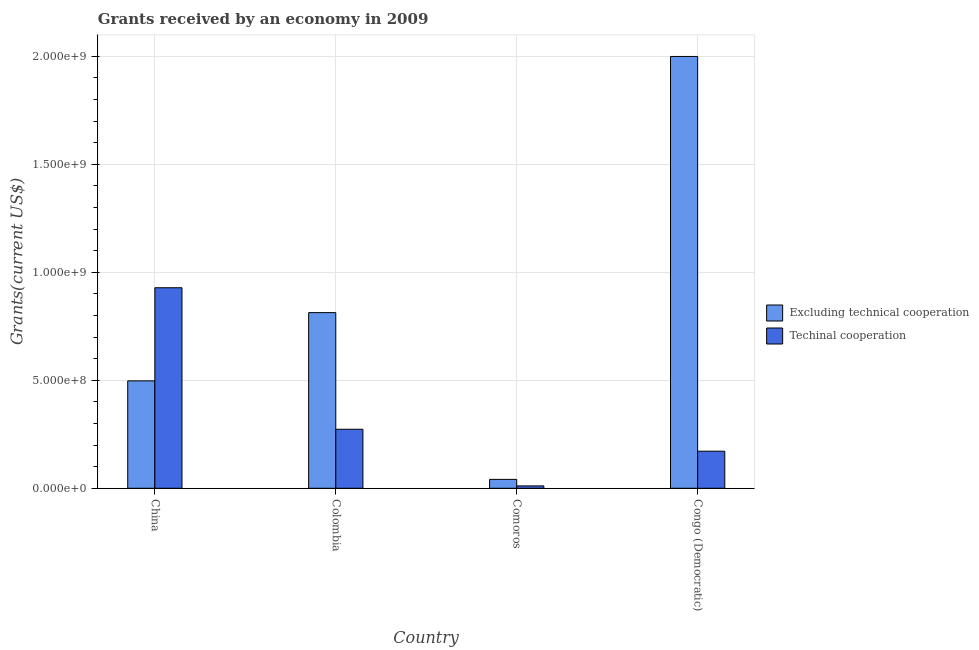What is the label of the 3rd group of bars from the left?
Make the answer very short. Comoros. In how many cases, is the number of bars for a given country not equal to the number of legend labels?
Keep it short and to the point. 0. What is the amount of grants received(including technical cooperation) in Colombia?
Your answer should be very brief. 2.73e+08. Across all countries, what is the maximum amount of grants received(excluding technical cooperation)?
Offer a terse response. 2.00e+09. Across all countries, what is the minimum amount of grants received(including technical cooperation)?
Your response must be concise. 1.10e+07. In which country was the amount of grants received(including technical cooperation) minimum?
Your answer should be compact. Comoros. What is the total amount of grants received(excluding technical cooperation) in the graph?
Ensure brevity in your answer.  3.35e+09. What is the difference between the amount of grants received(including technical cooperation) in China and that in Congo (Democratic)?
Your answer should be very brief. 7.57e+08. What is the difference between the amount of grants received(excluding technical cooperation) in Colombia and the amount of grants received(including technical cooperation) in Congo (Democratic)?
Your response must be concise. 6.42e+08. What is the average amount of grants received(including technical cooperation) per country?
Your answer should be very brief. 3.46e+08. What is the difference between the amount of grants received(excluding technical cooperation) and amount of grants received(including technical cooperation) in Comoros?
Your response must be concise. 3.01e+07. What is the ratio of the amount of grants received(including technical cooperation) in Colombia to that in Comoros?
Your answer should be compact. 24.75. Is the amount of grants received(including technical cooperation) in China less than that in Colombia?
Provide a short and direct response. No. Is the difference between the amount of grants received(including technical cooperation) in Comoros and Congo (Democratic) greater than the difference between the amount of grants received(excluding technical cooperation) in Comoros and Congo (Democratic)?
Give a very brief answer. Yes. What is the difference between the highest and the second highest amount of grants received(excluding technical cooperation)?
Provide a succinct answer. 1.19e+09. What is the difference between the highest and the lowest amount of grants received(excluding technical cooperation)?
Ensure brevity in your answer.  1.96e+09. What does the 2nd bar from the left in Congo (Democratic) represents?
Provide a succinct answer. Techinal cooperation. What does the 2nd bar from the right in Comoros represents?
Offer a very short reply. Excluding technical cooperation. Does the graph contain grids?
Make the answer very short. Yes. What is the title of the graph?
Provide a succinct answer. Grants received by an economy in 2009. What is the label or title of the X-axis?
Offer a terse response. Country. What is the label or title of the Y-axis?
Offer a terse response. Grants(current US$). What is the Grants(current US$) of Excluding technical cooperation in China?
Offer a very short reply. 4.97e+08. What is the Grants(current US$) of Techinal cooperation in China?
Your answer should be compact. 9.29e+08. What is the Grants(current US$) of Excluding technical cooperation in Colombia?
Your answer should be compact. 8.13e+08. What is the Grants(current US$) of Techinal cooperation in Colombia?
Your answer should be compact. 2.73e+08. What is the Grants(current US$) in Excluding technical cooperation in Comoros?
Provide a short and direct response. 4.12e+07. What is the Grants(current US$) of Techinal cooperation in Comoros?
Offer a very short reply. 1.10e+07. What is the Grants(current US$) of Excluding technical cooperation in Congo (Democratic)?
Keep it short and to the point. 2.00e+09. What is the Grants(current US$) in Techinal cooperation in Congo (Democratic)?
Keep it short and to the point. 1.72e+08. Across all countries, what is the maximum Grants(current US$) in Excluding technical cooperation?
Your response must be concise. 2.00e+09. Across all countries, what is the maximum Grants(current US$) of Techinal cooperation?
Your response must be concise. 9.29e+08. Across all countries, what is the minimum Grants(current US$) of Excluding technical cooperation?
Give a very brief answer. 4.12e+07. Across all countries, what is the minimum Grants(current US$) of Techinal cooperation?
Provide a succinct answer. 1.10e+07. What is the total Grants(current US$) in Excluding technical cooperation in the graph?
Keep it short and to the point. 3.35e+09. What is the total Grants(current US$) in Techinal cooperation in the graph?
Offer a terse response. 1.38e+09. What is the difference between the Grants(current US$) in Excluding technical cooperation in China and that in Colombia?
Offer a very short reply. -3.16e+08. What is the difference between the Grants(current US$) in Techinal cooperation in China and that in Colombia?
Give a very brief answer. 6.55e+08. What is the difference between the Grants(current US$) of Excluding technical cooperation in China and that in Comoros?
Your answer should be compact. 4.56e+08. What is the difference between the Grants(current US$) of Techinal cooperation in China and that in Comoros?
Ensure brevity in your answer.  9.18e+08. What is the difference between the Grants(current US$) in Excluding technical cooperation in China and that in Congo (Democratic)?
Provide a short and direct response. -1.50e+09. What is the difference between the Grants(current US$) of Techinal cooperation in China and that in Congo (Democratic)?
Offer a terse response. 7.57e+08. What is the difference between the Grants(current US$) in Excluding technical cooperation in Colombia and that in Comoros?
Provide a short and direct response. 7.72e+08. What is the difference between the Grants(current US$) in Techinal cooperation in Colombia and that in Comoros?
Keep it short and to the point. 2.62e+08. What is the difference between the Grants(current US$) in Excluding technical cooperation in Colombia and that in Congo (Democratic)?
Make the answer very short. -1.19e+09. What is the difference between the Grants(current US$) in Techinal cooperation in Colombia and that in Congo (Democratic)?
Offer a terse response. 1.02e+08. What is the difference between the Grants(current US$) in Excluding technical cooperation in Comoros and that in Congo (Democratic)?
Give a very brief answer. -1.96e+09. What is the difference between the Grants(current US$) in Techinal cooperation in Comoros and that in Congo (Democratic)?
Give a very brief answer. -1.61e+08. What is the difference between the Grants(current US$) in Excluding technical cooperation in China and the Grants(current US$) in Techinal cooperation in Colombia?
Offer a very short reply. 2.24e+08. What is the difference between the Grants(current US$) of Excluding technical cooperation in China and the Grants(current US$) of Techinal cooperation in Comoros?
Offer a very short reply. 4.86e+08. What is the difference between the Grants(current US$) of Excluding technical cooperation in China and the Grants(current US$) of Techinal cooperation in Congo (Democratic)?
Your answer should be compact. 3.26e+08. What is the difference between the Grants(current US$) in Excluding technical cooperation in Colombia and the Grants(current US$) in Techinal cooperation in Comoros?
Keep it short and to the point. 8.02e+08. What is the difference between the Grants(current US$) of Excluding technical cooperation in Colombia and the Grants(current US$) of Techinal cooperation in Congo (Democratic)?
Offer a terse response. 6.42e+08. What is the difference between the Grants(current US$) in Excluding technical cooperation in Comoros and the Grants(current US$) in Techinal cooperation in Congo (Democratic)?
Provide a short and direct response. -1.31e+08. What is the average Grants(current US$) in Excluding technical cooperation per country?
Ensure brevity in your answer.  8.38e+08. What is the average Grants(current US$) of Techinal cooperation per country?
Offer a very short reply. 3.46e+08. What is the difference between the Grants(current US$) in Excluding technical cooperation and Grants(current US$) in Techinal cooperation in China?
Your answer should be very brief. -4.31e+08. What is the difference between the Grants(current US$) in Excluding technical cooperation and Grants(current US$) in Techinal cooperation in Colombia?
Offer a very short reply. 5.40e+08. What is the difference between the Grants(current US$) of Excluding technical cooperation and Grants(current US$) of Techinal cooperation in Comoros?
Offer a terse response. 3.01e+07. What is the difference between the Grants(current US$) of Excluding technical cooperation and Grants(current US$) of Techinal cooperation in Congo (Democratic)?
Your answer should be very brief. 1.83e+09. What is the ratio of the Grants(current US$) in Excluding technical cooperation in China to that in Colombia?
Make the answer very short. 0.61. What is the ratio of the Grants(current US$) in Techinal cooperation in China to that in Colombia?
Your answer should be compact. 3.4. What is the ratio of the Grants(current US$) in Excluding technical cooperation in China to that in Comoros?
Ensure brevity in your answer.  12.08. What is the ratio of the Grants(current US$) of Techinal cooperation in China to that in Comoros?
Your response must be concise. 84.11. What is the ratio of the Grants(current US$) in Excluding technical cooperation in China to that in Congo (Democratic)?
Your response must be concise. 0.25. What is the ratio of the Grants(current US$) in Techinal cooperation in China to that in Congo (Democratic)?
Provide a short and direct response. 5.41. What is the ratio of the Grants(current US$) of Excluding technical cooperation in Colombia to that in Comoros?
Ensure brevity in your answer.  19.75. What is the ratio of the Grants(current US$) of Techinal cooperation in Colombia to that in Comoros?
Provide a short and direct response. 24.75. What is the ratio of the Grants(current US$) in Excluding technical cooperation in Colombia to that in Congo (Democratic)?
Provide a short and direct response. 0.41. What is the ratio of the Grants(current US$) in Techinal cooperation in Colombia to that in Congo (Democratic)?
Make the answer very short. 1.59. What is the ratio of the Grants(current US$) of Excluding technical cooperation in Comoros to that in Congo (Democratic)?
Your response must be concise. 0.02. What is the ratio of the Grants(current US$) in Techinal cooperation in Comoros to that in Congo (Democratic)?
Your answer should be compact. 0.06. What is the difference between the highest and the second highest Grants(current US$) in Excluding technical cooperation?
Provide a short and direct response. 1.19e+09. What is the difference between the highest and the second highest Grants(current US$) in Techinal cooperation?
Offer a terse response. 6.55e+08. What is the difference between the highest and the lowest Grants(current US$) in Excluding technical cooperation?
Make the answer very short. 1.96e+09. What is the difference between the highest and the lowest Grants(current US$) of Techinal cooperation?
Make the answer very short. 9.18e+08. 